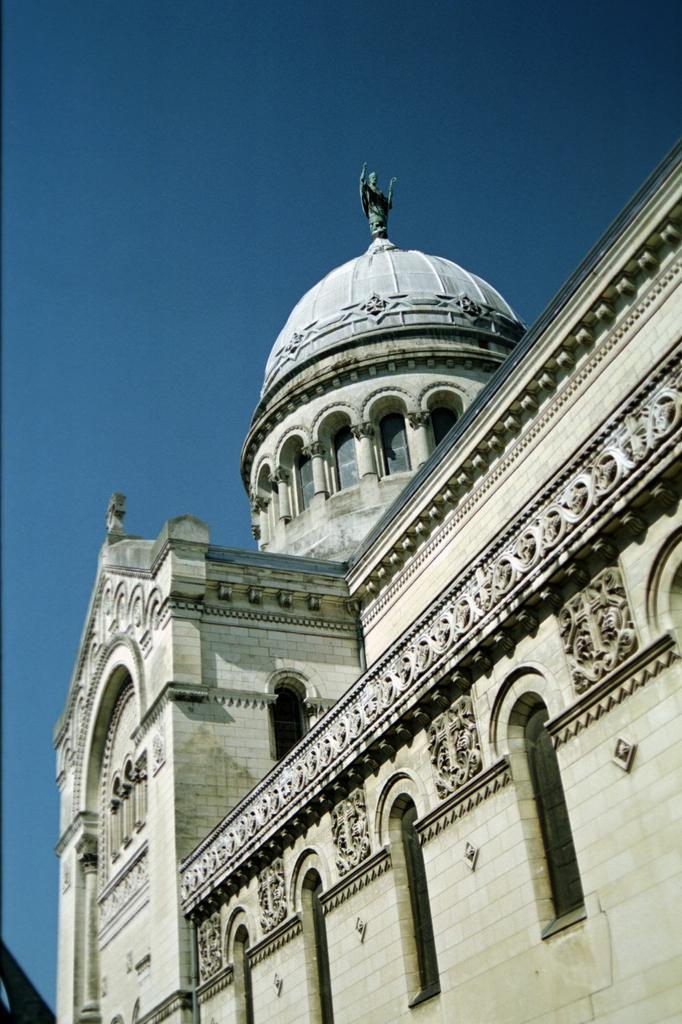What type of structure is present in the image? There is a building in the image. What can be seen above the building in the image? The sky is visible at the top of the image. How many bikes are parked next to the building in the image? There is no information about bikes or any other vehicles in the image; it only features a building and the sky. 